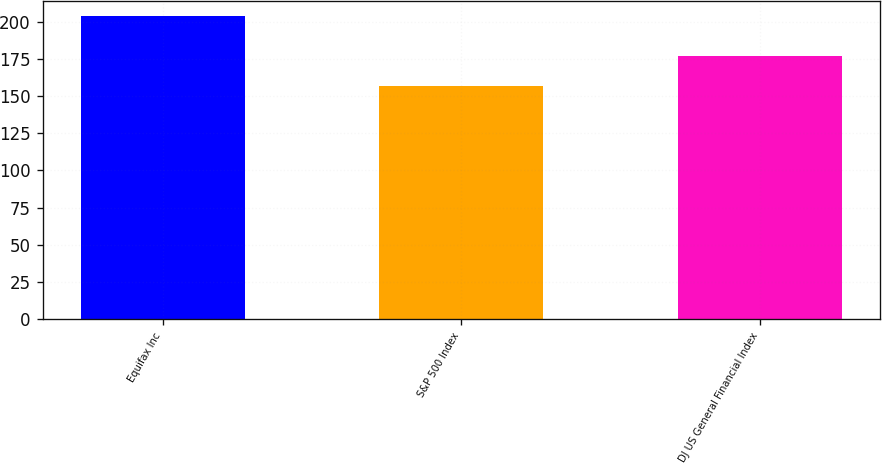Convert chart to OTSL. <chart><loc_0><loc_0><loc_500><loc_500><bar_chart><fcel>Equifax Inc<fcel>S&P 500 Index<fcel>DJ US General Financial Index<nl><fcel>203.78<fcel>156.82<fcel>177.16<nl></chart> 